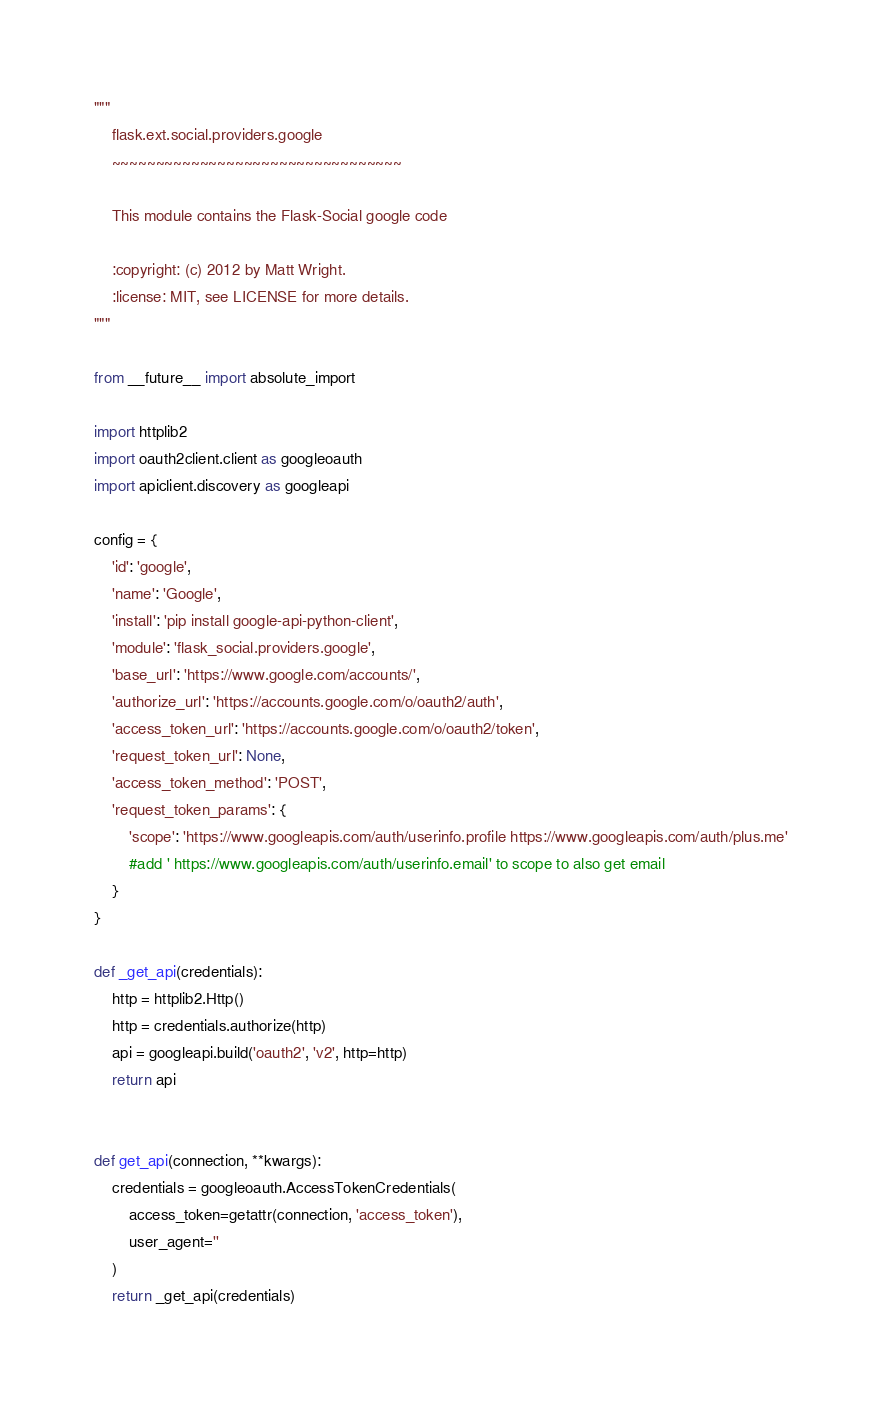Convert code to text. <code><loc_0><loc_0><loc_500><loc_500><_Python_>"""
    flask.ext.social.providers.google
    ~~~~~~~~~~~~~~~~~~~~~~~~~~~~~~~~~

    This module contains the Flask-Social google code

    :copyright: (c) 2012 by Matt Wright.
    :license: MIT, see LICENSE for more details.
"""

from __future__ import absolute_import

import httplib2
import oauth2client.client as googleoauth
import apiclient.discovery as googleapi

config = {
    'id': 'google',
    'name': 'Google',
    'install': 'pip install google-api-python-client',
    'module': 'flask_social.providers.google',
    'base_url': 'https://www.google.com/accounts/',
    'authorize_url': 'https://accounts.google.com/o/oauth2/auth',
    'access_token_url': 'https://accounts.google.com/o/oauth2/token',
    'request_token_url': None,
    'access_token_method': 'POST',
    'request_token_params': {
        'scope': 'https://www.googleapis.com/auth/userinfo.profile https://www.googleapis.com/auth/plus.me'
        #add ' https://www.googleapis.com/auth/userinfo.email' to scope to also get email
    }
}

def _get_api(credentials):
    http = httplib2.Http()
    http = credentials.authorize(http)
    api = googleapi.build('oauth2', 'v2', http=http)
    return api


def get_api(connection, **kwargs):
    credentials = googleoauth.AccessTokenCredentials(
        access_token=getattr(connection, 'access_token'),
        user_agent=''
    )
    return _get_api(credentials)

</code> 